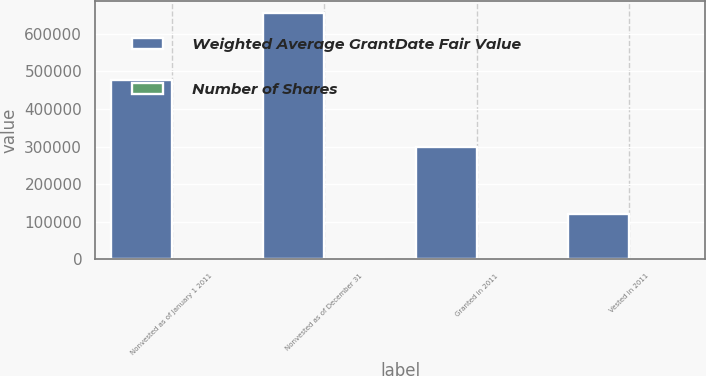Convert chart. <chart><loc_0><loc_0><loc_500><loc_500><stacked_bar_chart><ecel><fcel>Nonvested as of January 1 2011<fcel>Nonvested as of December 31<fcel>Granted in 2011<fcel>Vested in 2011<nl><fcel>Weighted Average GrantDate Fair Value<fcel>475914<fcel>654696<fcel>297859<fcel>121573<nl><fcel>Number of Shares<fcel>51.26<fcel>45.26<fcel>38.44<fcel>41.1<nl></chart> 